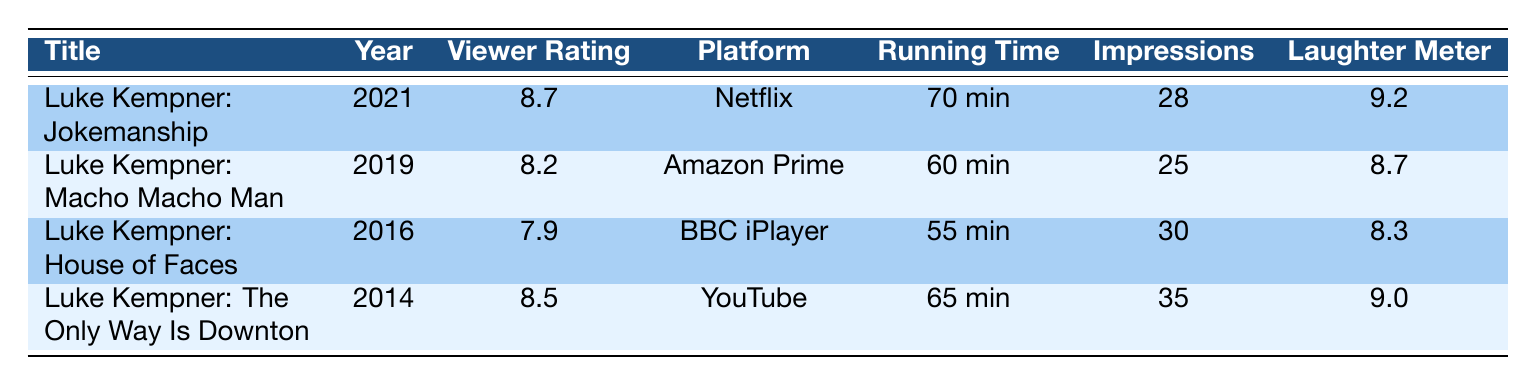What is the viewer rating of "Luke Kempner: Jokemanship"? The table directly lists the viewer rating for "Luke Kempner: Jokemanship" under the "Viewer Rating" column. It shows the value is 8.7.
Answer: 8.7 Which comedy special has the highest audience laughter meter? By comparing the "Laughter Meter" values listed for each comedy special, "Luke Kempner: Jokemanship" has the highest score at 9.2.
Answer: Luke Kempner: Jokemanship What is the difference in viewer ratings between "House of Faces" and "The Only Way Is Downton"? The viewer rating for "House of Faces" is 7.9, and for "The Only Way Is Downton," it is 8.5. The difference is calculated as 8.5 - 7.9 = 0.6.
Answer: 0.6 How many more impressions were performed in "The Only Way Is Downton" compared to "Macho Macho Man"? "The Only Way Is Downton" had 35 impressions while "Macho Macho Man" had 25. Calculating the difference gives 35 - 25 = 10.
Answer: 10 Was "Luke Kempner: Jokemanship" released before 2019? "Jokemanship" was released in 2021, which is after 2019. Therefore, the answer is no, it was not released before.
Answer: No What is the average running time of all the comedy specials? The running times are 70, 60, 55, and 65 minutes. Adding these totals gives 70 + 60 + 55 + 65 = 250. Dividing by the number of specials (4) results in an average running time of 250 / 4 = 62.5 minutes.
Answer: 62.5 minutes Which platform features the special with the lowest viewer rating? Looking at the "Viewer Rating" column, "House of Faces" has the lowest rating at 7.9, which is available on BBC iPlayer. Therefore, BBC iPlayer features the lowest rated special.
Answer: BBC iPlayer What special performed the most impressions? From the "Impressions" column, "The Only Way Is Downton" shows the highest number of impressions at 35.
Answer: The Only Way Is Downton Did any special receive a topicality score above 9? Checking the "Topicality Score" column reveals that both "Jokemanship" (9.5) and "The Only Way Is Downton" (9.3) scored above 9, confirming the answer is yes.
Answer: Yes 